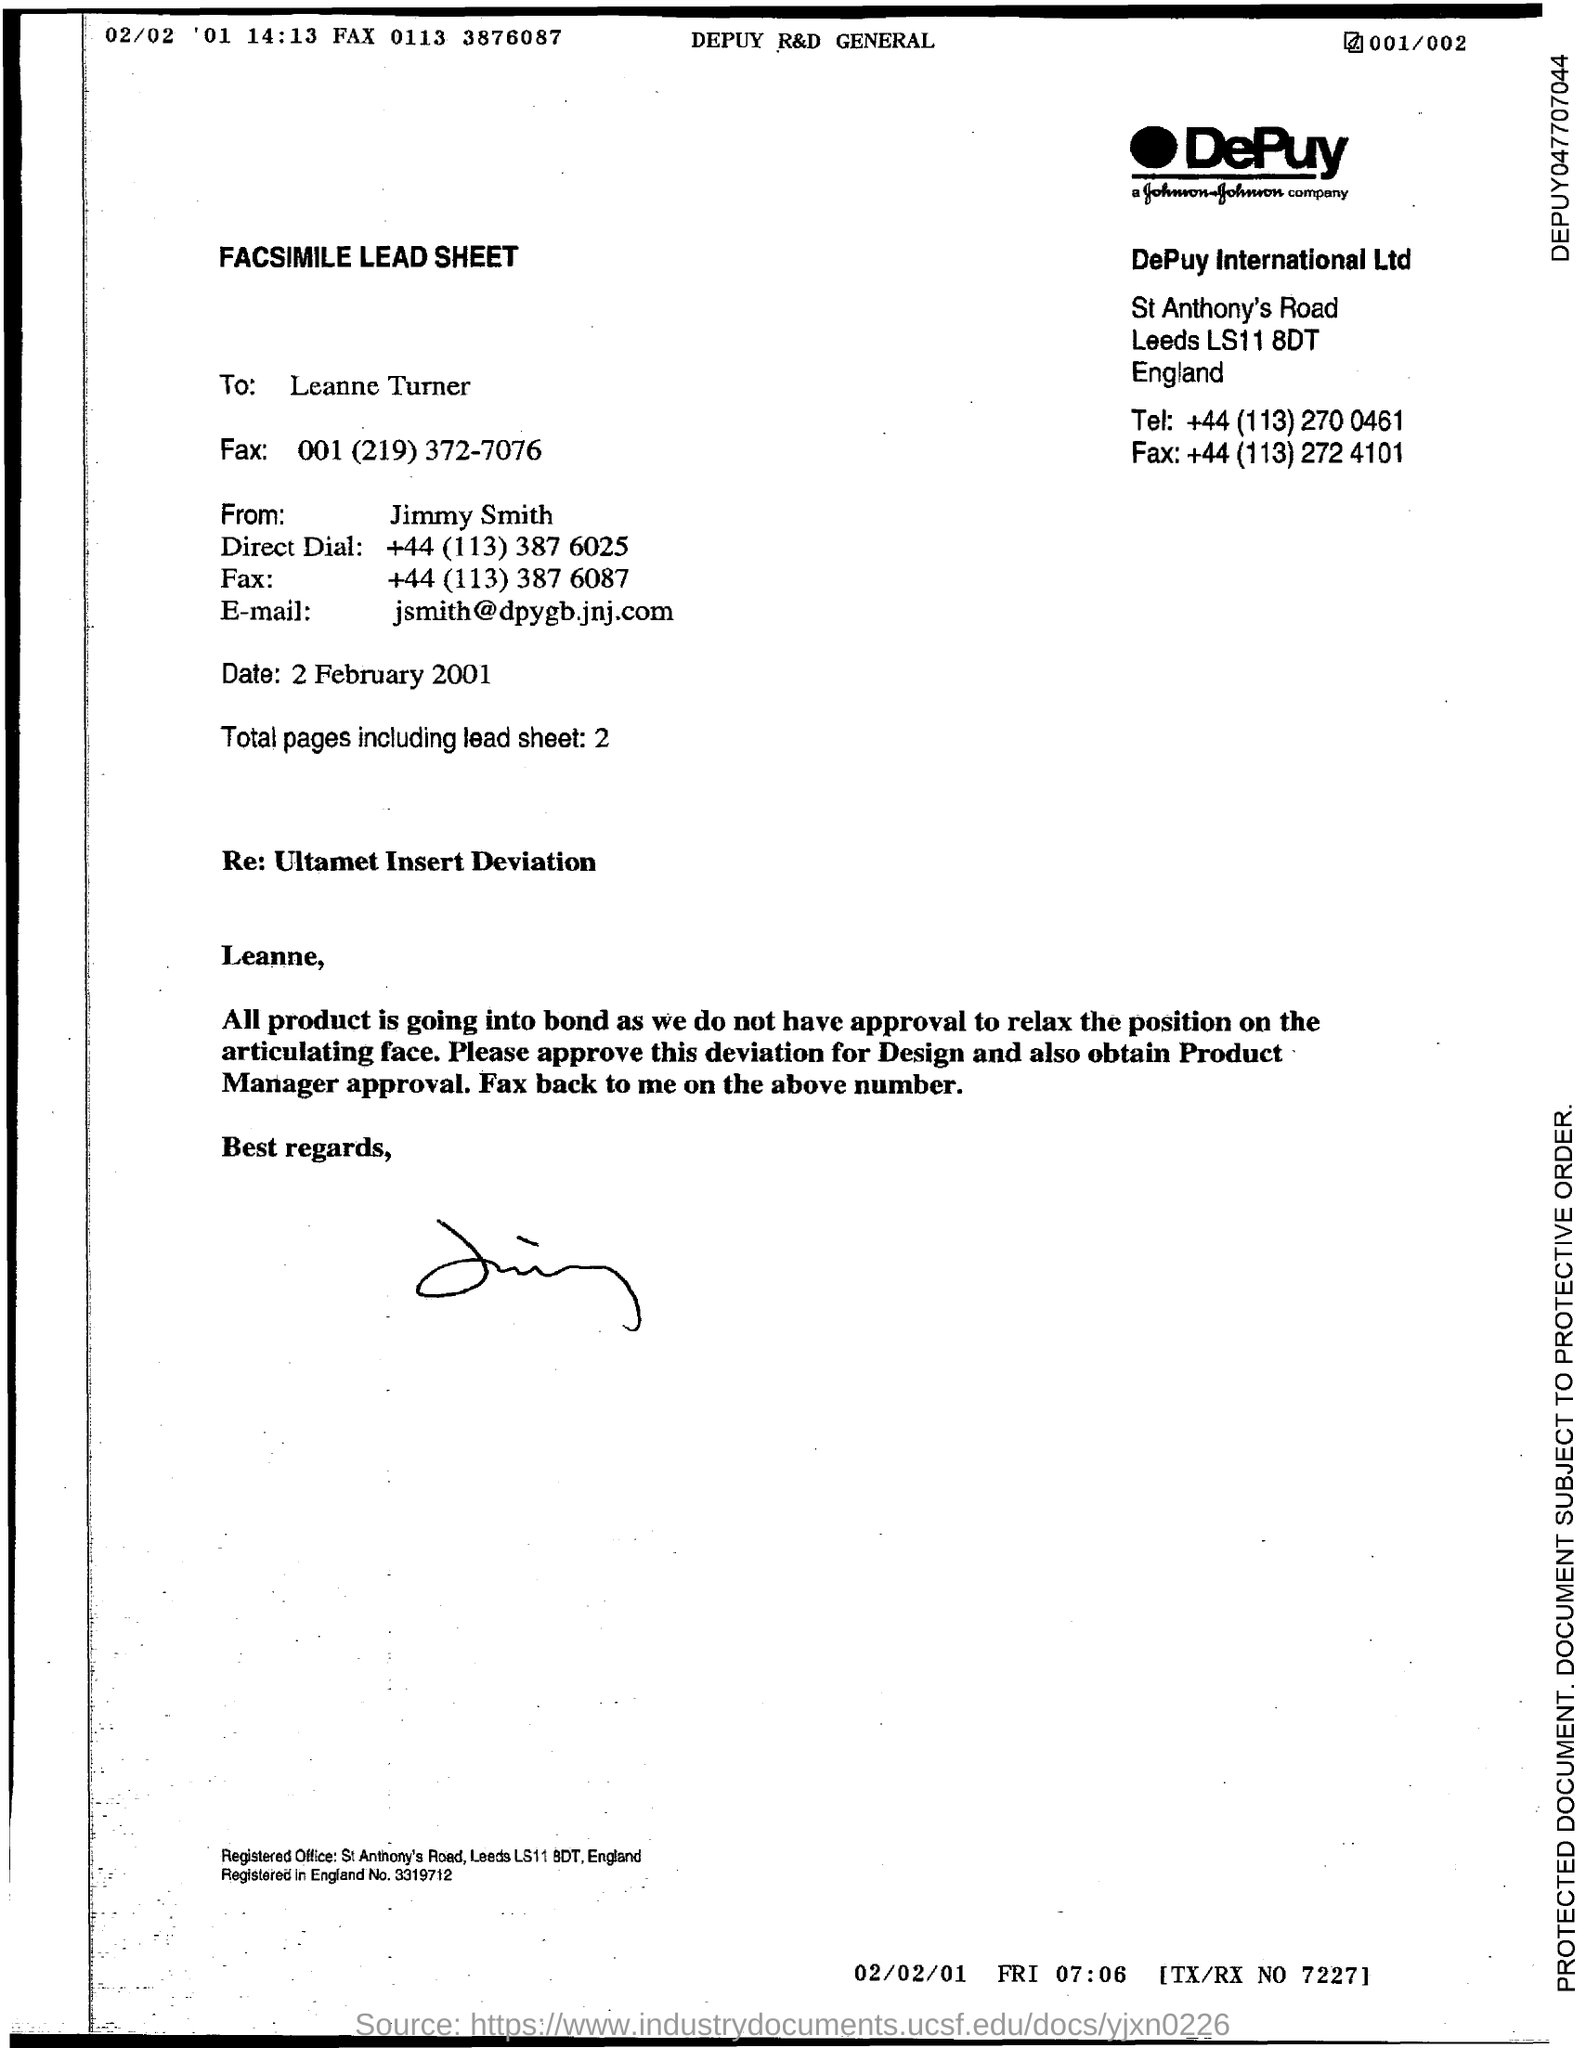List a handful of essential elements in this visual. The email address is [jsmith@dpygb.jnj.com](mailto:jsmith@dpygb.jnj.com). The total number of pages, including the lead sheet, is two. 